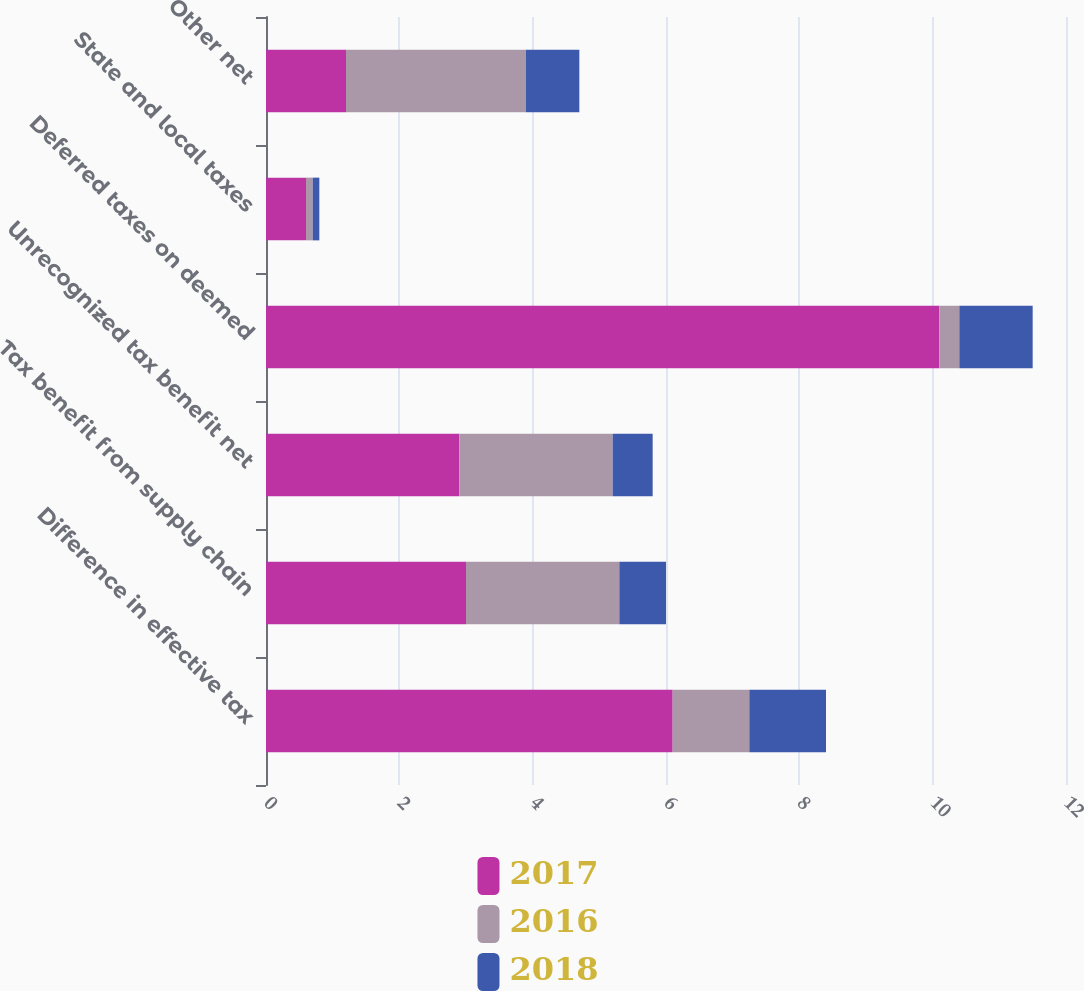<chart> <loc_0><loc_0><loc_500><loc_500><stacked_bar_chart><ecel><fcel>Difference in effective tax<fcel>Tax benefit from supply chain<fcel>Unrecognized tax benefit net<fcel>Deferred taxes on deemed<fcel>State and local taxes<fcel>Other net<nl><fcel>2017<fcel>6.1<fcel>3<fcel>2.9<fcel>10.1<fcel>0.6<fcel>1.2<nl><fcel>2016<fcel>1.15<fcel>2.3<fcel>2.3<fcel>0.3<fcel>0.1<fcel>2.7<nl><fcel>2018<fcel>1.15<fcel>0.7<fcel>0.6<fcel>1.1<fcel>0.1<fcel>0.8<nl></chart> 